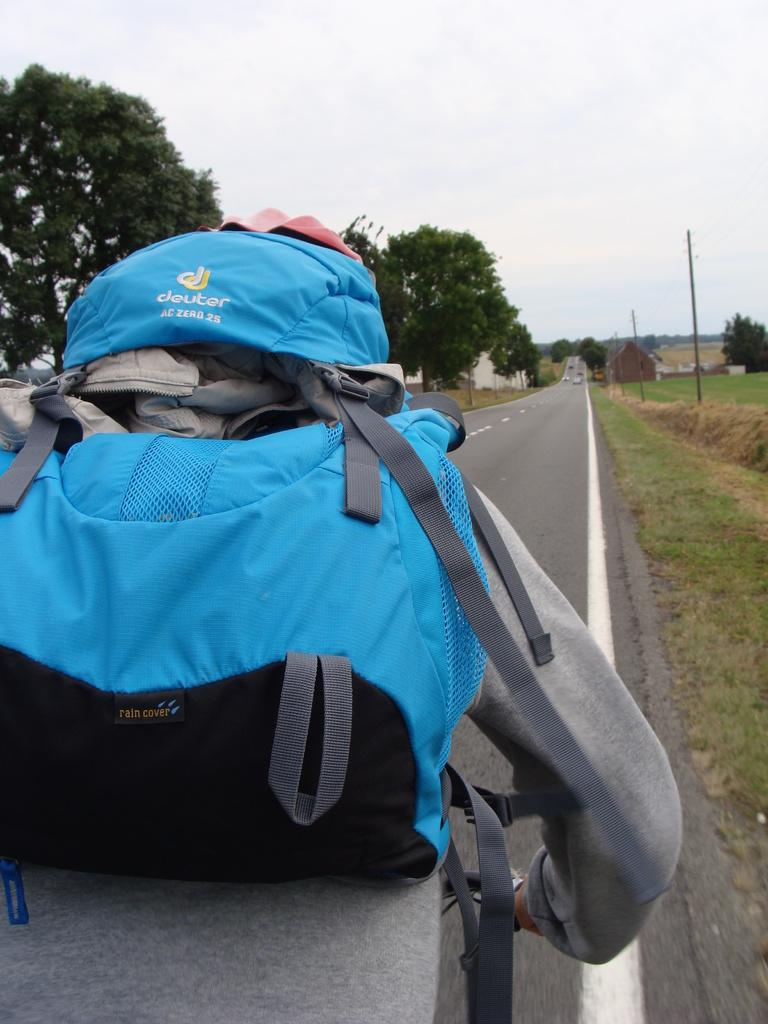Who is present in the image? There is a person in the image. What is the person carrying in the image? The person is carrying a blue backpack. What type of environment is depicted in the image? There is grass and trees visible in the image, suggesting a natural setting. What type of attention is the person receiving at the party in the image? There is no party present in the image, and therefore no attention being received by the person. 